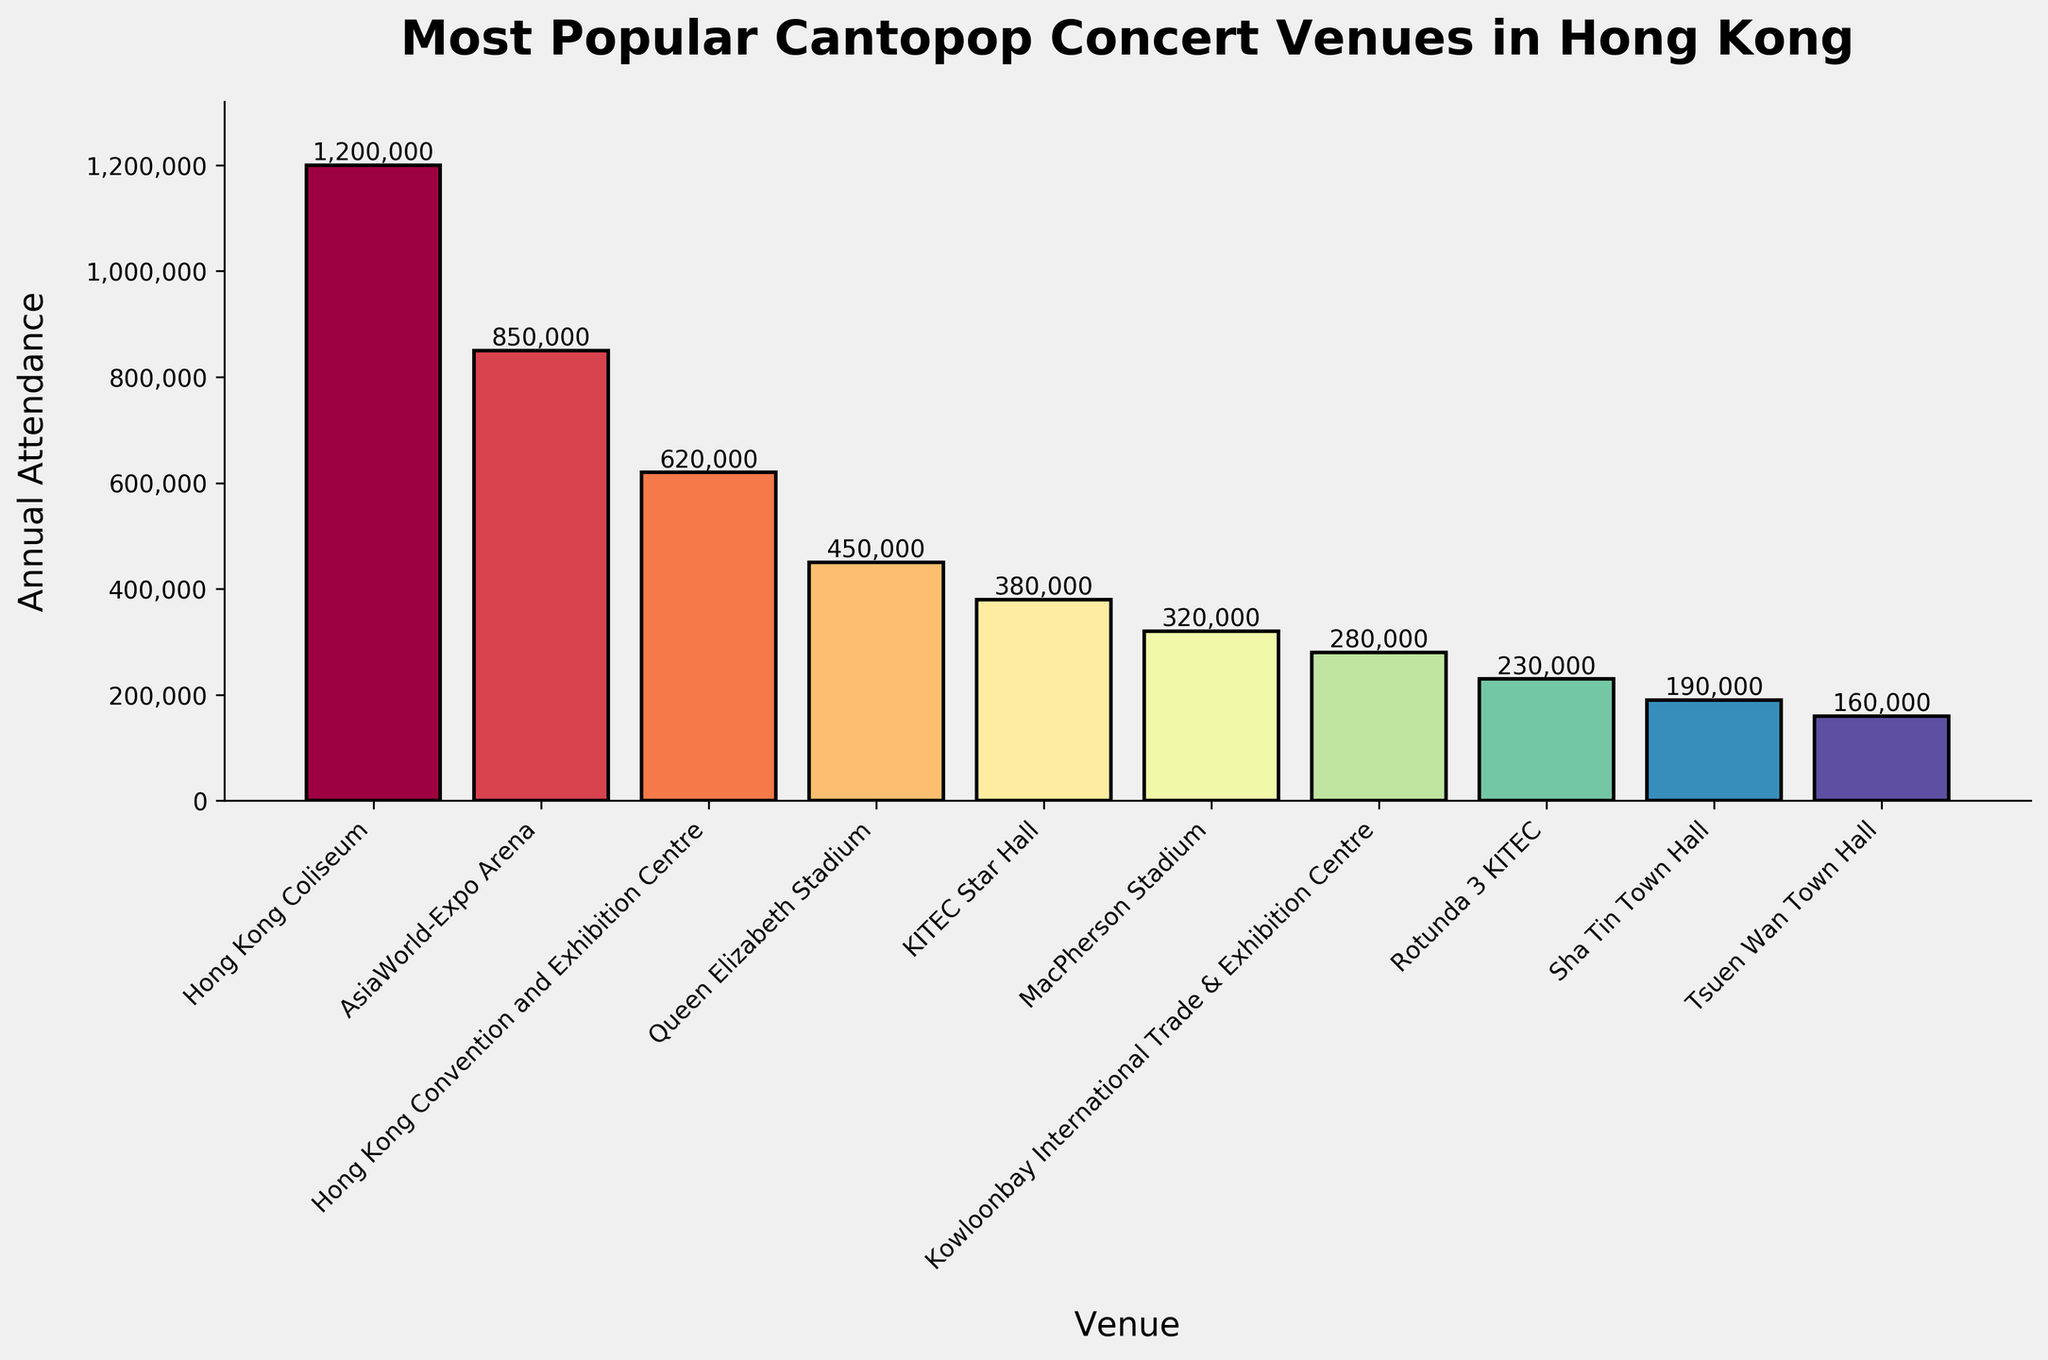Is the Hong Kong Coliseum the only venue with annual attendance exceeding one million? Examine the height of the bars to see if any others reach or exceed one million. The Hong Kong Coliseum is the only venue that surpasses one million annual attendance.
Answer: Yes Which venue has the lowest annual attendance, and how much is it? Find the shortest bar on the chart. The venue with the shortest bar is the one with the lowest attendance. Tsuen Wan Town Hall has the lowest annual attendance, which is 160,000.
Answer: Tsuen Wan Town Hall, 160,000 What is the combined annual attendance of AsiaWorld-Expo Arena and Hong Kong Convention and Exhibition Centre? Sum the attendance figures for AsiaWorld-Expo Arena and Hong Kong Convention and Exhibition Centre (850,000 and 620,000). The combined attendance is 850,000 + 620,000 = 1,470,000.
Answer: 1,470,000 How many venues have an annual attendance of at least 500,000? Count the bars that reach or exceed the 500,000 attendance mark. The venues are Hong Kong Coliseum, AsiaWorld-Expo Arena, and Hong Kong Convention and Exhibition Centre. Therefore, there are 3 venues.
Answer: 3 What is the difference in annual attendance between Queen Elizabeth Stadium and MacPherson Stadium? Subtract the attendance of MacPherson Stadium from that of Queen Elizabeth Stadium (450,000 - 320,000). The difference is 450,000 - 320,000 = 130,000.
Answer: 130,000 Which venues have an annual attendance between 200,000 and 400,000? Identify the bars whose heights fall within the 200,000 to 400,000 range. These venues are KITEC Star Hall, MacPherson Stadium, Kowloonbay International Trade & Exhibition Centre, and Rotunda 3 KITEC.
Answer: KITEC Star Hall, MacPherson Stadium, Kowloonbay International Trade & Exhibition Centre, Rotunda 3 KITEC How much higher is the annual attendance of the Hong Kong Coliseum compared to the AsiaWorld-Expo Arena? Subtract the annual attendance of AsiaWorld-Expo Arena from that of Hong Kong Coliseum (1,200,000 - 850,000). The difference is 350,000.
Answer: 350,000 Among the listed venues, which one has an annual attendance closest to the average annual attendance of all venues? First, calculate the average attendance: (1,200,000 + 850,000 + 620,000 + 450,000 + 380,000 + 320,000 + 280,000 + 230,000 + 190,000 + 160,000) / 10 ≈ 468,000. Then find the venue with attendance closest to this average. Queen Elizabeth Stadium, with an annual attendance of 450,000, is the closest to the average.
Answer: Queen Elizabeth Stadium 